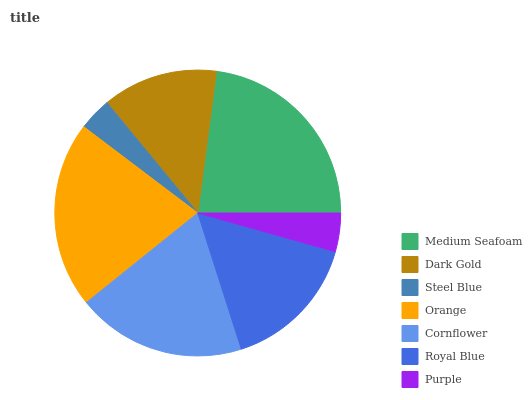Is Steel Blue the minimum?
Answer yes or no. Yes. Is Medium Seafoam the maximum?
Answer yes or no. Yes. Is Dark Gold the minimum?
Answer yes or no. No. Is Dark Gold the maximum?
Answer yes or no. No. Is Medium Seafoam greater than Dark Gold?
Answer yes or no. Yes. Is Dark Gold less than Medium Seafoam?
Answer yes or no. Yes. Is Dark Gold greater than Medium Seafoam?
Answer yes or no. No. Is Medium Seafoam less than Dark Gold?
Answer yes or no. No. Is Royal Blue the high median?
Answer yes or no. Yes. Is Royal Blue the low median?
Answer yes or no. Yes. Is Cornflower the high median?
Answer yes or no. No. Is Purple the low median?
Answer yes or no. No. 